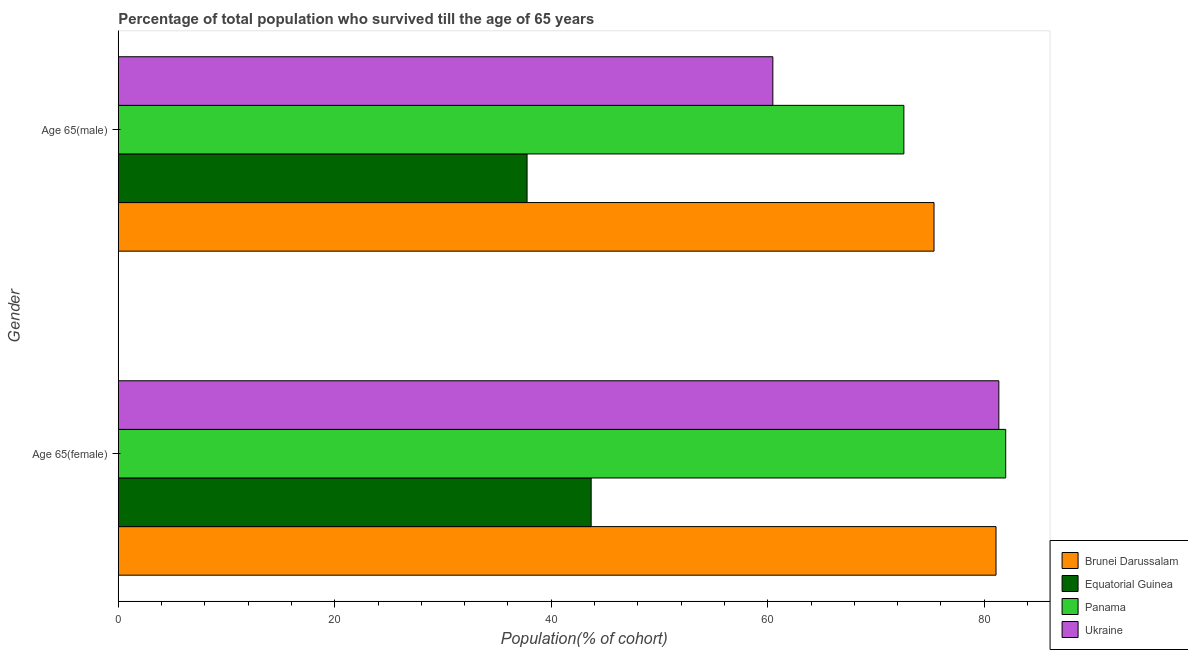How many different coloured bars are there?
Offer a very short reply. 4. How many groups of bars are there?
Provide a succinct answer. 2. Are the number of bars on each tick of the Y-axis equal?
Keep it short and to the point. Yes. How many bars are there on the 2nd tick from the bottom?
Your answer should be very brief. 4. What is the label of the 1st group of bars from the top?
Provide a succinct answer. Age 65(male). What is the percentage of female population who survived till age of 65 in Panama?
Make the answer very short. 81.98. Across all countries, what is the maximum percentage of male population who survived till age of 65?
Offer a very short reply. 75.36. Across all countries, what is the minimum percentage of female population who survived till age of 65?
Keep it short and to the point. 43.69. In which country was the percentage of female population who survived till age of 65 maximum?
Give a very brief answer. Panama. In which country was the percentage of female population who survived till age of 65 minimum?
Your answer should be very brief. Equatorial Guinea. What is the total percentage of male population who survived till age of 65 in the graph?
Offer a very short reply. 246.17. What is the difference between the percentage of male population who survived till age of 65 in Panama and that in Equatorial Guinea?
Offer a terse response. 34.81. What is the difference between the percentage of male population who survived till age of 65 in Equatorial Guinea and the percentage of female population who survived till age of 65 in Panama?
Keep it short and to the point. -44.22. What is the average percentage of female population who survived till age of 65 per country?
Ensure brevity in your answer.  72.03. What is the difference between the percentage of female population who survived till age of 65 and percentage of male population who survived till age of 65 in Brunei Darussalam?
Offer a terse response. 5.73. In how many countries, is the percentage of male population who survived till age of 65 greater than 16 %?
Provide a succinct answer. 4. What is the ratio of the percentage of female population who survived till age of 65 in Panama to that in Brunei Darussalam?
Keep it short and to the point. 1.01. Is the percentage of male population who survived till age of 65 in Equatorial Guinea less than that in Brunei Darussalam?
Your response must be concise. Yes. What does the 3rd bar from the top in Age 65(female) represents?
Offer a terse response. Equatorial Guinea. What does the 4th bar from the bottom in Age 65(male) represents?
Provide a succinct answer. Ukraine. How many bars are there?
Provide a succinct answer. 8. Are the values on the major ticks of X-axis written in scientific E-notation?
Make the answer very short. No. How are the legend labels stacked?
Give a very brief answer. Vertical. What is the title of the graph?
Offer a very short reply. Percentage of total population who survived till the age of 65 years. Does "France" appear as one of the legend labels in the graph?
Your answer should be very brief. No. What is the label or title of the X-axis?
Your response must be concise. Population(% of cohort). What is the label or title of the Y-axis?
Make the answer very short. Gender. What is the Population(% of cohort) of Brunei Darussalam in Age 65(female)?
Provide a succinct answer. 81.09. What is the Population(% of cohort) in Equatorial Guinea in Age 65(female)?
Ensure brevity in your answer.  43.69. What is the Population(% of cohort) in Panama in Age 65(female)?
Offer a very short reply. 81.98. What is the Population(% of cohort) in Ukraine in Age 65(female)?
Offer a terse response. 81.35. What is the Population(% of cohort) of Brunei Darussalam in Age 65(male)?
Your answer should be compact. 75.36. What is the Population(% of cohort) in Equatorial Guinea in Age 65(male)?
Your answer should be compact. 37.76. What is the Population(% of cohort) of Panama in Age 65(male)?
Provide a succinct answer. 72.58. What is the Population(% of cohort) of Ukraine in Age 65(male)?
Offer a very short reply. 60.47. Across all Gender, what is the maximum Population(% of cohort) in Brunei Darussalam?
Keep it short and to the point. 81.09. Across all Gender, what is the maximum Population(% of cohort) in Equatorial Guinea?
Ensure brevity in your answer.  43.69. Across all Gender, what is the maximum Population(% of cohort) of Panama?
Give a very brief answer. 81.98. Across all Gender, what is the maximum Population(% of cohort) in Ukraine?
Your response must be concise. 81.35. Across all Gender, what is the minimum Population(% of cohort) of Brunei Darussalam?
Keep it short and to the point. 75.36. Across all Gender, what is the minimum Population(% of cohort) of Equatorial Guinea?
Your answer should be very brief. 37.76. Across all Gender, what is the minimum Population(% of cohort) in Panama?
Your response must be concise. 72.58. Across all Gender, what is the minimum Population(% of cohort) of Ukraine?
Offer a very short reply. 60.47. What is the total Population(% of cohort) in Brunei Darussalam in the graph?
Ensure brevity in your answer.  156.45. What is the total Population(% of cohort) in Equatorial Guinea in the graph?
Keep it short and to the point. 81.45. What is the total Population(% of cohort) of Panama in the graph?
Your answer should be compact. 154.56. What is the total Population(% of cohort) in Ukraine in the graph?
Offer a very short reply. 141.82. What is the difference between the Population(% of cohort) in Brunei Darussalam in Age 65(female) and that in Age 65(male)?
Your answer should be compact. 5.73. What is the difference between the Population(% of cohort) of Equatorial Guinea in Age 65(female) and that in Age 65(male)?
Your answer should be compact. 5.92. What is the difference between the Population(% of cohort) in Panama in Age 65(female) and that in Age 65(male)?
Ensure brevity in your answer.  9.41. What is the difference between the Population(% of cohort) of Ukraine in Age 65(female) and that in Age 65(male)?
Keep it short and to the point. 20.88. What is the difference between the Population(% of cohort) of Brunei Darussalam in Age 65(female) and the Population(% of cohort) of Equatorial Guinea in Age 65(male)?
Ensure brevity in your answer.  43.32. What is the difference between the Population(% of cohort) of Brunei Darussalam in Age 65(female) and the Population(% of cohort) of Panama in Age 65(male)?
Offer a very short reply. 8.51. What is the difference between the Population(% of cohort) of Brunei Darussalam in Age 65(female) and the Population(% of cohort) of Ukraine in Age 65(male)?
Ensure brevity in your answer.  20.62. What is the difference between the Population(% of cohort) in Equatorial Guinea in Age 65(female) and the Population(% of cohort) in Panama in Age 65(male)?
Ensure brevity in your answer.  -28.89. What is the difference between the Population(% of cohort) in Equatorial Guinea in Age 65(female) and the Population(% of cohort) in Ukraine in Age 65(male)?
Give a very brief answer. -16.79. What is the difference between the Population(% of cohort) of Panama in Age 65(female) and the Population(% of cohort) of Ukraine in Age 65(male)?
Provide a short and direct response. 21.51. What is the average Population(% of cohort) of Brunei Darussalam per Gender?
Your answer should be very brief. 78.22. What is the average Population(% of cohort) of Equatorial Guinea per Gender?
Offer a very short reply. 40.73. What is the average Population(% of cohort) of Panama per Gender?
Make the answer very short. 77.28. What is the average Population(% of cohort) in Ukraine per Gender?
Make the answer very short. 70.91. What is the difference between the Population(% of cohort) of Brunei Darussalam and Population(% of cohort) of Equatorial Guinea in Age 65(female)?
Keep it short and to the point. 37.4. What is the difference between the Population(% of cohort) of Brunei Darussalam and Population(% of cohort) of Panama in Age 65(female)?
Provide a short and direct response. -0.9. What is the difference between the Population(% of cohort) in Brunei Darussalam and Population(% of cohort) in Ukraine in Age 65(female)?
Your answer should be very brief. -0.26. What is the difference between the Population(% of cohort) in Equatorial Guinea and Population(% of cohort) in Panama in Age 65(female)?
Your answer should be very brief. -38.3. What is the difference between the Population(% of cohort) in Equatorial Guinea and Population(% of cohort) in Ukraine in Age 65(female)?
Offer a terse response. -37.66. What is the difference between the Population(% of cohort) of Panama and Population(% of cohort) of Ukraine in Age 65(female)?
Provide a succinct answer. 0.63. What is the difference between the Population(% of cohort) in Brunei Darussalam and Population(% of cohort) in Equatorial Guinea in Age 65(male)?
Your response must be concise. 37.6. What is the difference between the Population(% of cohort) of Brunei Darussalam and Population(% of cohort) of Panama in Age 65(male)?
Make the answer very short. 2.78. What is the difference between the Population(% of cohort) in Brunei Darussalam and Population(% of cohort) in Ukraine in Age 65(male)?
Your answer should be very brief. 14.89. What is the difference between the Population(% of cohort) in Equatorial Guinea and Population(% of cohort) in Panama in Age 65(male)?
Make the answer very short. -34.81. What is the difference between the Population(% of cohort) in Equatorial Guinea and Population(% of cohort) in Ukraine in Age 65(male)?
Your answer should be very brief. -22.71. What is the difference between the Population(% of cohort) in Panama and Population(% of cohort) in Ukraine in Age 65(male)?
Make the answer very short. 12.1. What is the ratio of the Population(% of cohort) in Brunei Darussalam in Age 65(female) to that in Age 65(male)?
Make the answer very short. 1.08. What is the ratio of the Population(% of cohort) in Equatorial Guinea in Age 65(female) to that in Age 65(male)?
Provide a short and direct response. 1.16. What is the ratio of the Population(% of cohort) of Panama in Age 65(female) to that in Age 65(male)?
Provide a short and direct response. 1.13. What is the ratio of the Population(% of cohort) in Ukraine in Age 65(female) to that in Age 65(male)?
Offer a very short reply. 1.35. What is the difference between the highest and the second highest Population(% of cohort) of Brunei Darussalam?
Your response must be concise. 5.73. What is the difference between the highest and the second highest Population(% of cohort) of Equatorial Guinea?
Provide a succinct answer. 5.92. What is the difference between the highest and the second highest Population(% of cohort) of Panama?
Your response must be concise. 9.41. What is the difference between the highest and the second highest Population(% of cohort) of Ukraine?
Offer a terse response. 20.88. What is the difference between the highest and the lowest Population(% of cohort) in Brunei Darussalam?
Make the answer very short. 5.73. What is the difference between the highest and the lowest Population(% of cohort) of Equatorial Guinea?
Offer a very short reply. 5.92. What is the difference between the highest and the lowest Population(% of cohort) of Panama?
Provide a short and direct response. 9.41. What is the difference between the highest and the lowest Population(% of cohort) of Ukraine?
Provide a succinct answer. 20.88. 